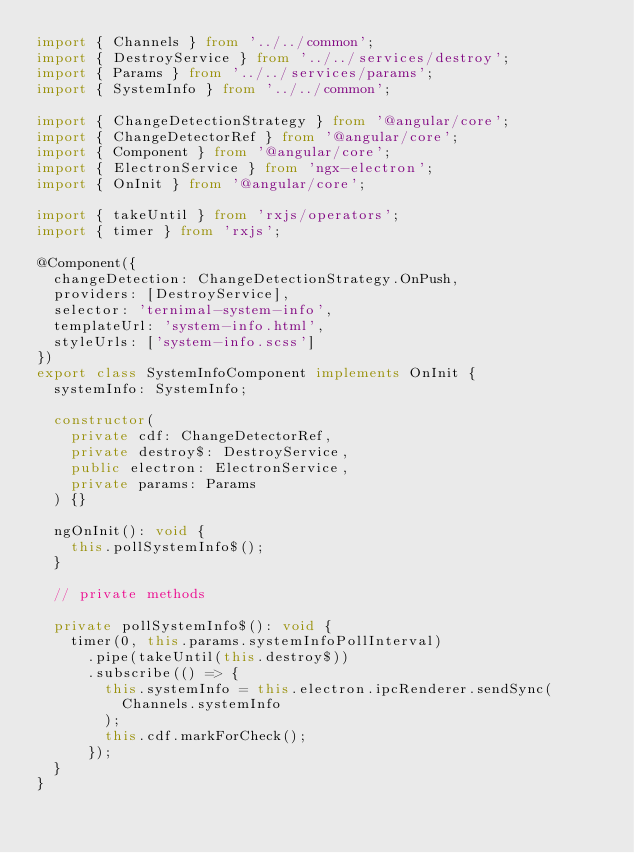<code> <loc_0><loc_0><loc_500><loc_500><_TypeScript_>import { Channels } from '../../common';
import { DestroyService } from '../../services/destroy';
import { Params } from '../../services/params';
import { SystemInfo } from '../../common';

import { ChangeDetectionStrategy } from '@angular/core';
import { ChangeDetectorRef } from '@angular/core';
import { Component } from '@angular/core';
import { ElectronService } from 'ngx-electron';
import { OnInit } from '@angular/core';

import { takeUntil } from 'rxjs/operators';
import { timer } from 'rxjs';

@Component({
  changeDetection: ChangeDetectionStrategy.OnPush,
  providers: [DestroyService],
  selector: 'ternimal-system-info',
  templateUrl: 'system-info.html',
  styleUrls: ['system-info.scss']
})
export class SystemInfoComponent implements OnInit {
  systemInfo: SystemInfo;

  constructor(
    private cdf: ChangeDetectorRef,
    private destroy$: DestroyService,
    public electron: ElectronService,
    private params: Params
  ) {}

  ngOnInit(): void {
    this.pollSystemInfo$();
  }

  // private methods

  private pollSystemInfo$(): void {
    timer(0, this.params.systemInfoPollInterval)
      .pipe(takeUntil(this.destroy$))
      .subscribe(() => {
        this.systemInfo = this.electron.ipcRenderer.sendSync(
          Channels.systemInfo
        );
        this.cdf.markForCheck();
      });
  }
}
</code> 